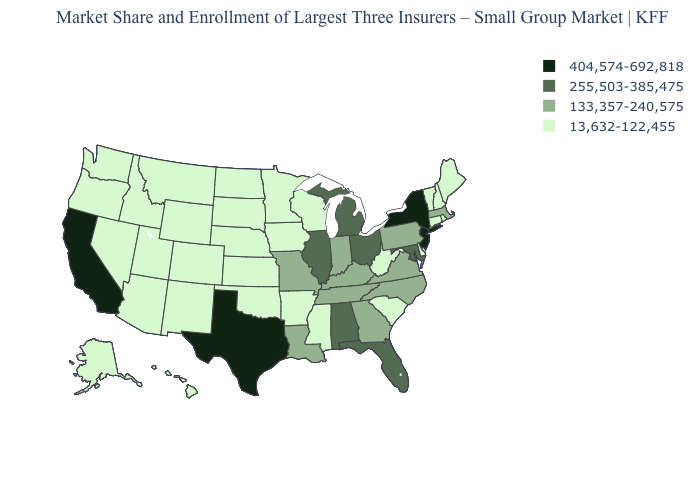Name the states that have a value in the range 255,503-385,475?
Write a very short answer. Alabama, Florida, Illinois, Maryland, Michigan, Ohio. What is the value of Hawaii?
Give a very brief answer. 13,632-122,455. Name the states that have a value in the range 133,357-240,575?
Answer briefly. Georgia, Indiana, Kentucky, Louisiana, Massachusetts, Missouri, North Carolina, Pennsylvania, Tennessee, Virginia. Name the states that have a value in the range 255,503-385,475?
Answer briefly. Alabama, Florida, Illinois, Maryland, Michigan, Ohio. Name the states that have a value in the range 133,357-240,575?
Short answer required. Georgia, Indiana, Kentucky, Louisiana, Massachusetts, Missouri, North Carolina, Pennsylvania, Tennessee, Virginia. Name the states that have a value in the range 404,574-692,818?
Write a very short answer. California, New Jersey, New York, Texas. Among the states that border Iowa , which have the highest value?
Short answer required. Illinois. Name the states that have a value in the range 255,503-385,475?
Keep it brief. Alabama, Florida, Illinois, Maryland, Michigan, Ohio. Name the states that have a value in the range 13,632-122,455?
Short answer required. Alaska, Arizona, Arkansas, Colorado, Connecticut, Delaware, Hawaii, Idaho, Iowa, Kansas, Maine, Minnesota, Mississippi, Montana, Nebraska, Nevada, New Hampshire, New Mexico, North Dakota, Oklahoma, Oregon, Rhode Island, South Carolina, South Dakota, Utah, Vermont, Washington, West Virginia, Wisconsin, Wyoming. Name the states that have a value in the range 133,357-240,575?
Keep it brief. Georgia, Indiana, Kentucky, Louisiana, Massachusetts, Missouri, North Carolina, Pennsylvania, Tennessee, Virginia. Is the legend a continuous bar?
Be succinct. No. How many symbols are there in the legend?
Write a very short answer. 4. Is the legend a continuous bar?
Keep it brief. No. Name the states that have a value in the range 13,632-122,455?
Short answer required. Alaska, Arizona, Arkansas, Colorado, Connecticut, Delaware, Hawaii, Idaho, Iowa, Kansas, Maine, Minnesota, Mississippi, Montana, Nebraska, Nevada, New Hampshire, New Mexico, North Dakota, Oklahoma, Oregon, Rhode Island, South Carolina, South Dakota, Utah, Vermont, Washington, West Virginia, Wisconsin, Wyoming. Name the states that have a value in the range 13,632-122,455?
Keep it brief. Alaska, Arizona, Arkansas, Colorado, Connecticut, Delaware, Hawaii, Idaho, Iowa, Kansas, Maine, Minnesota, Mississippi, Montana, Nebraska, Nevada, New Hampshire, New Mexico, North Dakota, Oklahoma, Oregon, Rhode Island, South Carolina, South Dakota, Utah, Vermont, Washington, West Virginia, Wisconsin, Wyoming. 